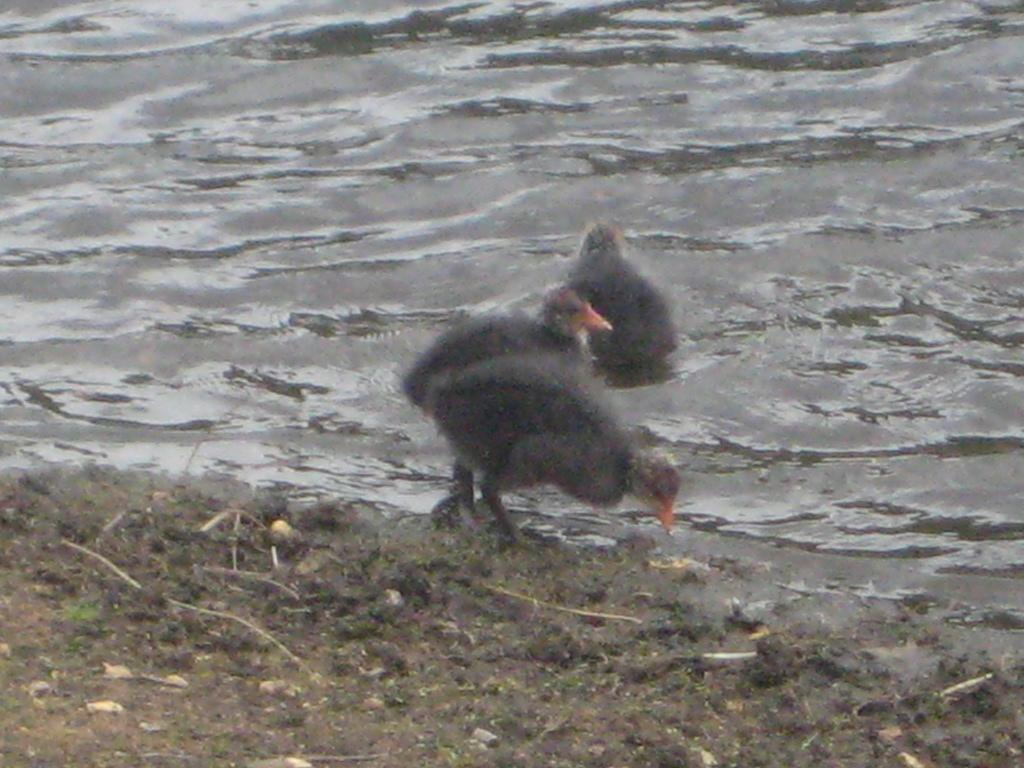What is located in the center of the image? There are birds in the center of the image. What can be seen at the bottom of the image? The ground is present at the bottom of the image. What is visible at the top of the image? Water is visible at the top of the image. Where is the chair located in the image? There is no chair present in the image. What type of breakfast is being served in the image? There is no breakfast present in the image. 